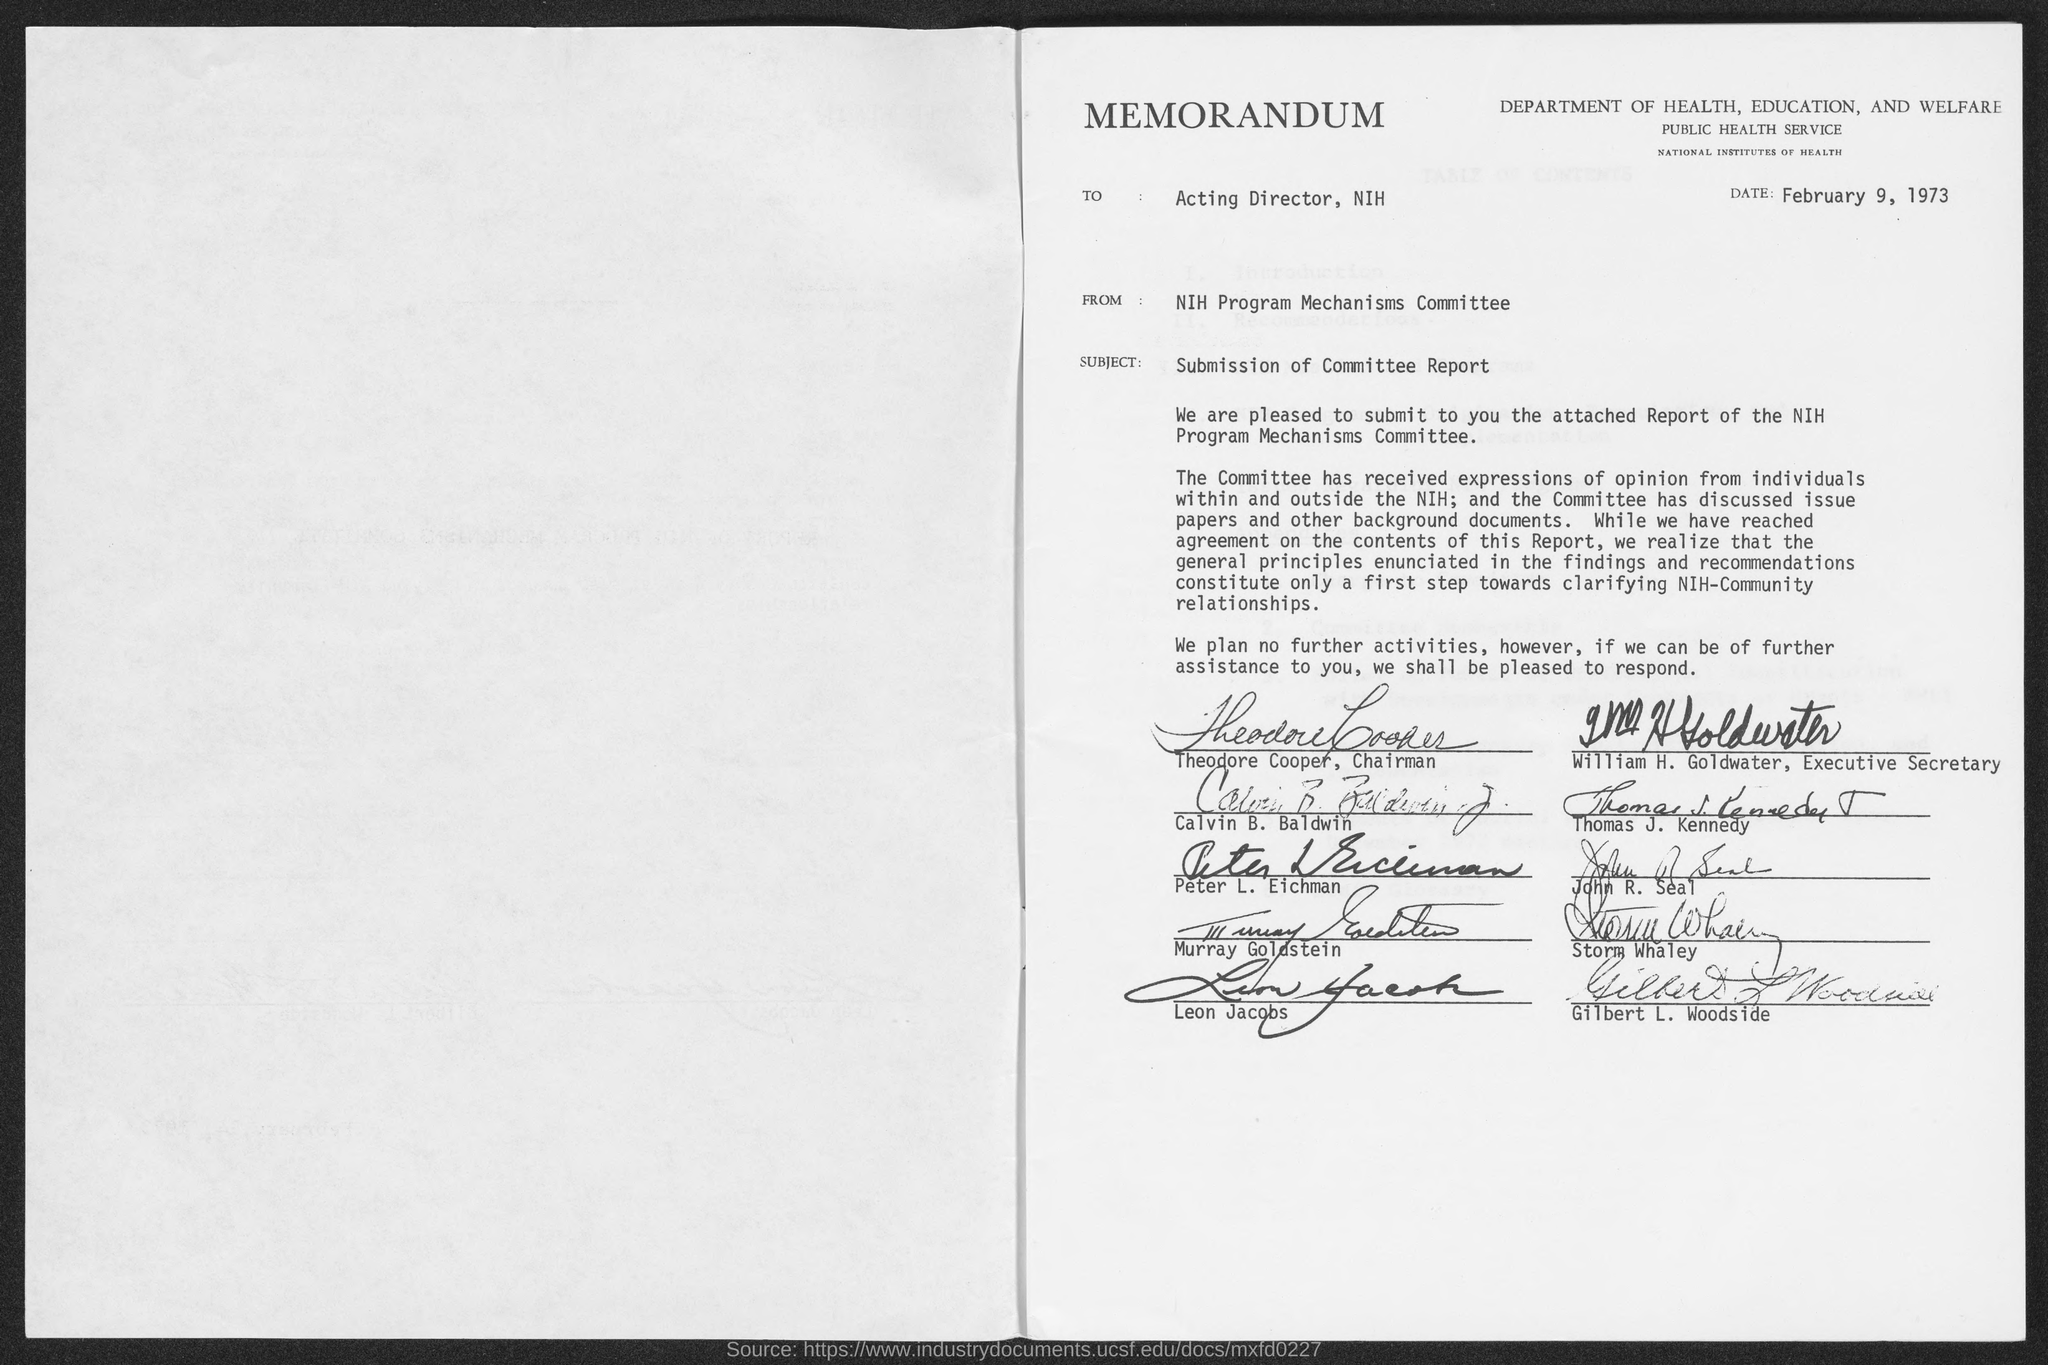Highlight a few significant elements in this photo. The Department of Health, Education and Welfare is chaired by Theodore Cooper. The memorandum is dated February 9, 1973. The subject of the memorandum is the submission of the committee report. The subject of the memorandum is seeking information on the origin or source of the document. Specifically, the memorandum is interested in determining the from address of the document, which appears to be from the National Institute of Health's Program Mechanisms Committee. William H. Goldwater is the executive secretary of the Department of Health, Education, and Welfare. 